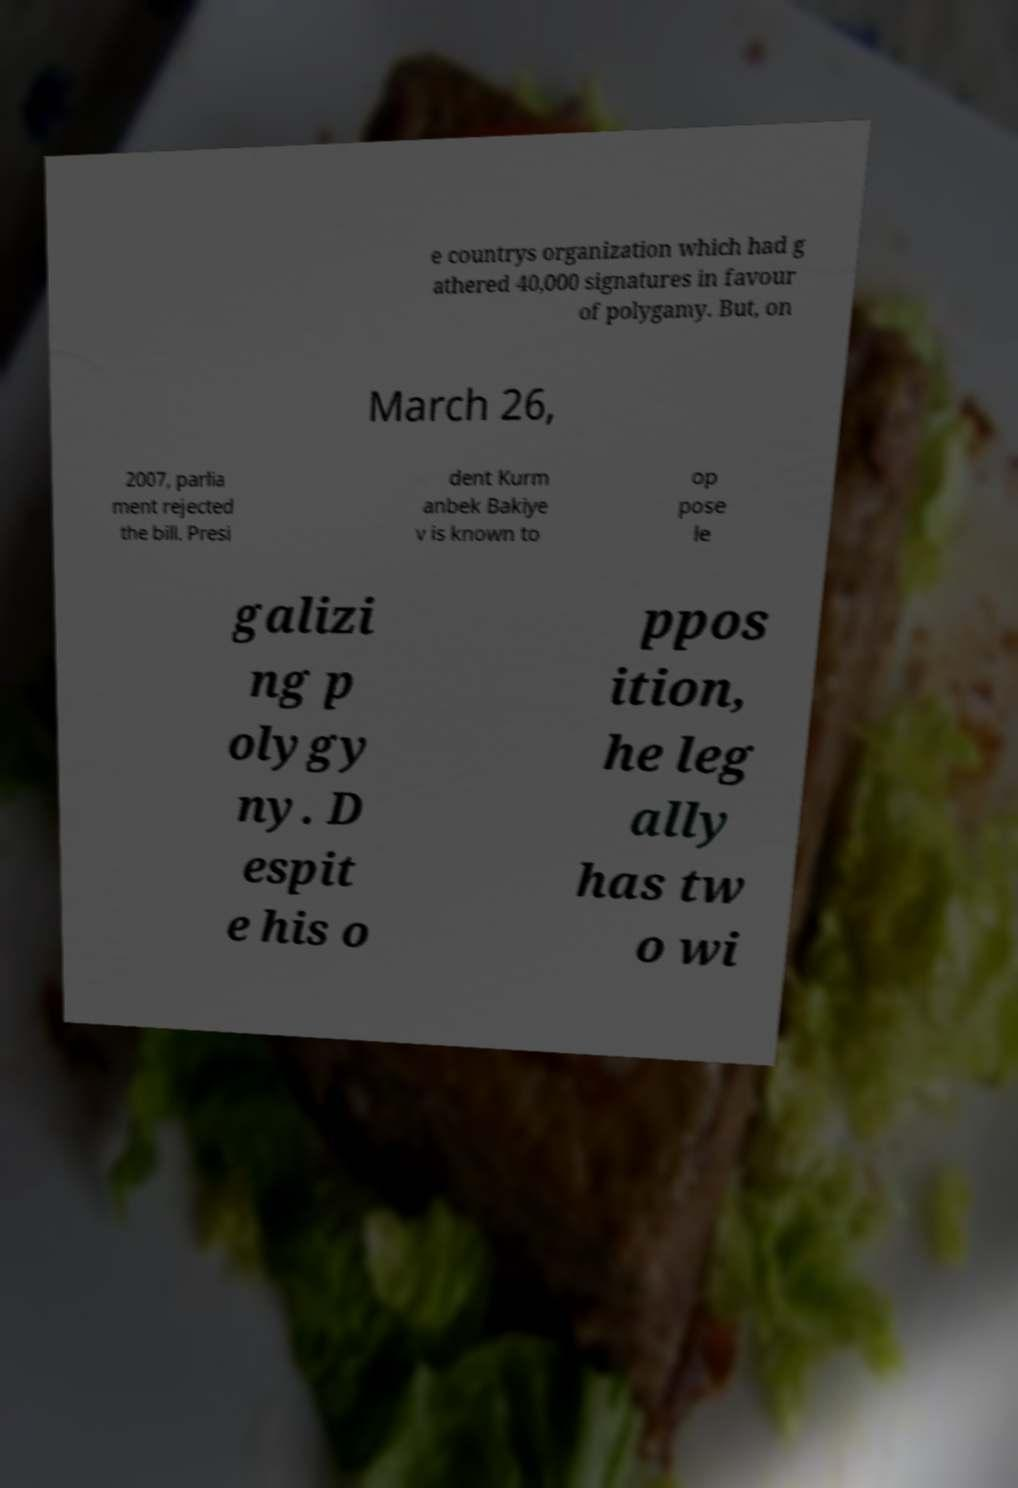Could you assist in decoding the text presented in this image and type it out clearly? e countrys organization which had g athered 40,000 signatures in favour of polygamy. But, on March 26, 2007, parlia ment rejected the bill. Presi dent Kurm anbek Bakiye v is known to op pose le galizi ng p olygy ny. D espit e his o ppos ition, he leg ally has tw o wi 